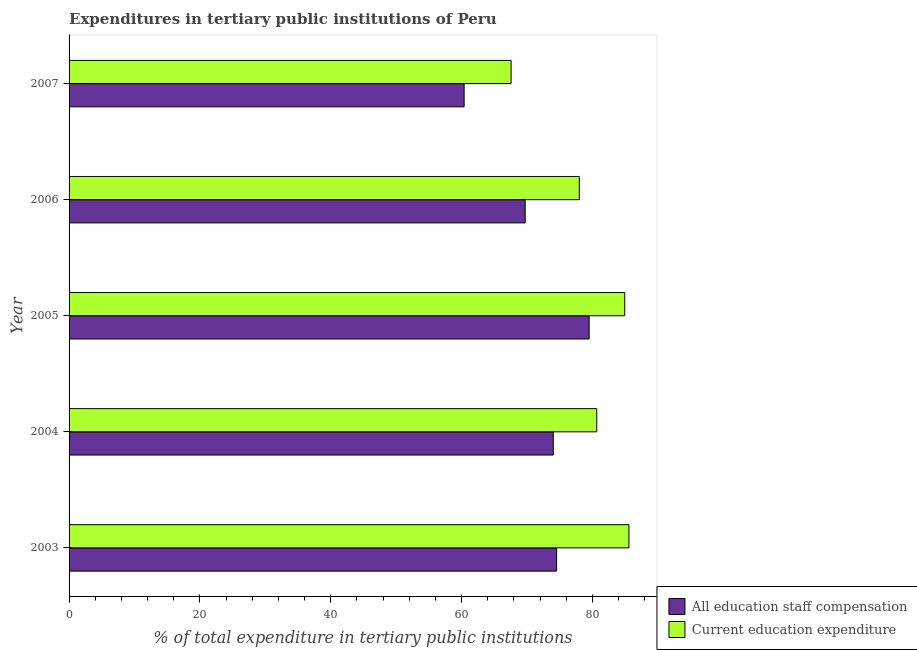How many groups of bars are there?
Your answer should be compact. 5. Are the number of bars on each tick of the Y-axis equal?
Ensure brevity in your answer.  Yes. How many bars are there on the 5th tick from the bottom?
Your answer should be compact. 2. What is the label of the 3rd group of bars from the top?
Keep it short and to the point. 2005. In how many cases, is the number of bars for a given year not equal to the number of legend labels?
Provide a short and direct response. 0. What is the expenditure in education in 2007?
Provide a short and direct response. 67.57. Across all years, what is the maximum expenditure in education?
Provide a short and direct response. 85.58. Across all years, what is the minimum expenditure in education?
Provide a short and direct response. 67.57. What is the total expenditure in education in the graph?
Provide a succinct answer. 396.74. What is the difference between the expenditure in education in 2003 and that in 2007?
Your answer should be compact. 18.01. What is the difference between the expenditure in education in 2006 and the expenditure in staff compensation in 2007?
Your answer should be very brief. 17.61. What is the average expenditure in staff compensation per year?
Your answer should be very brief. 71.63. In the year 2004, what is the difference between the expenditure in staff compensation and expenditure in education?
Provide a succinct answer. -6.65. In how many years, is the expenditure in education greater than 28 %?
Your answer should be very brief. 5. What is the ratio of the expenditure in staff compensation in 2006 to that in 2007?
Your answer should be compact. 1.16. Is the difference between the expenditure in education in 2003 and 2007 greater than the difference between the expenditure in staff compensation in 2003 and 2007?
Your response must be concise. Yes. What is the difference between the highest and the second highest expenditure in education?
Offer a terse response. 0.64. What is the difference between the highest and the lowest expenditure in staff compensation?
Your answer should be very brief. 19.11. What does the 2nd bar from the top in 2007 represents?
Keep it short and to the point. All education staff compensation. What does the 1st bar from the bottom in 2007 represents?
Ensure brevity in your answer.  All education staff compensation. What is the difference between two consecutive major ticks on the X-axis?
Your answer should be very brief. 20. Where does the legend appear in the graph?
Make the answer very short. Bottom right. What is the title of the graph?
Your answer should be compact. Expenditures in tertiary public institutions of Peru. What is the label or title of the X-axis?
Ensure brevity in your answer.  % of total expenditure in tertiary public institutions. What is the % of total expenditure in tertiary public institutions in All education staff compensation in 2003?
Your answer should be very brief. 74.52. What is the % of total expenditure in tertiary public institutions in Current education expenditure in 2003?
Your response must be concise. 85.58. What is the % of total expenditure in tertiary public institutions in All education staff compensation in 2004?
Offer a terse response. 74.02. What is the % of total expenditure in tertiary public institutions in Current education expenditure in 2004?
Provide a short and direct response. 80.66. What is the % of total expenditure in tertiary public institutions in All education staff compensation in 2005?
Your response must be concise. 79.5. What is the % of total expenditure in tertiary public institutions in Current education expenditure in 2005?
Give a very brief answer. 84.94. What is the % of total expenditure in tertiary public institutions of All education staff compensation in 2006?
Provide a succinct answer. 69.72. What is the % of total expenditure in tertiary public institutions in Current education expenditure in 2006?
Offer a very short reply. 77.99. What is the % of total expenditure in tertiary public institutions in All education staff compensation in 2007?
Give a very brief answer. 60.39. What is the % of total expenditure in tertiary public institutions of Current education expenditure in 2007?
Your response must be concise. 67.57. Across all years, what is the maximum % of total expenditure in tertiary public institutions in All education staff compensation?
Offer a terse response. 79.5. Across all years, what is the maximum % of total expenditure in tertiary public institutions of Current education expenditure?
Your answer should be compact. 85.58. Across all years, what is the minimum % of total expenditure in tertiary public institutions in All education staff compensation?
Offer a terse response. 60.39. Across all years, what is the minimum % of total expenditure in tertiary public institutions in Current education expenditure?
Your response must be concise. 67.57. What is the total % of total expenditure in tertiary public institutions of All education staff compensation in the graph?
Your response must be concise. 358.14. What is the total % of total expenditure in tertiary public institutions in Current education expenditure in the graph?
Your answer should be compact. 396.74. What is the difference between the % of total expenditure in tertiary public institutions in All education staff compensation in 2003 and that in 2004?
Keep it short and to the point. 0.51. What is the difference between the % of total expenditure in tertiary public institutions of Current education expenditure in 2003 and that in 2004?
Keep it short and to the point. 4.92. What is the difference between the % of total expenditure in tertiary public institutions in All education staff compensation in 2003 and that in 2005?
Give a very brief answer. -4.97. What is the difference between the % of total expenditure in tertiary public institutions of Current education expenditure in 2003 and that in 2005?
Provide a short and direct response. 0.64. What is the difference between the % of total expenditure in tertiary public institutions of All education staff compensation in 2003 and that in 2006?
Your response must be concise. 4.8. What is the difference between the % of total expenditure in tertiary public institutions of Current education expenditure in 2003 and that in 2006?
Your response must be concise. 7.59. What is the difference between the % of total expenditure in tertiary public institutions in All education staff compensation in 2003 and that in 2007?
Provide a short and direct response. 14.14. What is the difference between the % of total expenditure in tertiary public institutions in Current education expenditure in 2003 and that in 2007?
Offer a terse response. 18.01. What is the difference between the % of total expenditure in tertiary public institutions in All education staff compensation in 2004 and that in 2005?
Your answer should be very brief. -5.48. What is the difference between the % of total expenditure in tertiary public institutions of Current education expenditure in 2004 and that in 2005?
Your answer should be very brief. -4.28. What is the difference between the % of total expenditure in tertiary public institutions of All education staff compensation in 2004 and that in 2006?
Your answer should be very brief. 4.29. What is the difference between the % of total expenditure in tertiary public institutions in Current education expenditure in 2004 and that in 2006?
Keep it short and to the point. 2.67. What is the difference between the % of total expenditure in tertiary public institutions of All education staff compensation in 2004 and that in 2007?
Offer a terse response. 13.63. What is the difference between the % of total expenditure in tertiary public institutions of Current education expenditure in 2004 and that in 2007?
Offer a very short reply. 13.09. What is the difference between the % of total expenditure in tertiary public institutions of All education staff compensation in 2005 and that in 2006?
Give a very brief answer. 9.78. What is the difference between the % of total expenditure in tertiary public institutions of Current education expenditure in 2005 and that in 2006?
Provide a succinct answer. 6.94. What is the difference between the % of total expenditure in tertiary public institutions in All education staff compensation in 2005 and that in 2007?
Offer a very short reply. 19.11. What is the difference between the % of total expenditure in tertiary public institutions of Current education expenditure in 2005 and that in 2007?
Offer a very short reply. 17.37. What is the difference between the % of total expenditure in tertiary public institutions of All education staff compensation in 2006 and that in 2007?
Make the answer very short. 9.33. What is the difference between the % of total expenditure in tertiary public institutions in Current education expenditure in 2006 and that in 2007?
Offer a terse response. 10.43. What is the difference between the % of total expenditure in tertiary public institutions in All education staff compensation in 2003 and the % of total expenditure in tertiary public institutions in Current education expenditure in 2004?
Make the answer very short. -6.14. What is the difference between the % of total expenditure in tertiary public institutions in All education staff compensation in 2003 and the % of total expenditure in tertiary public institutions in Current education expenditure in 2005?
Provide a short and direct response. -10.41. What is the difference between the % of total expenditure in tertiary public institutions of All education staff compensation in 2003 and the % of total expenditure in tertiary public institutions of Current education expenditure in 2006?
Your answer should be very brief. -3.47. What is the difference between the % of total expenditure in tertiary public institutions of All education staff compensation in 2003 and the % of total expenditure in tertiary public institutions of Current education expenditure in 2007?
Make the answer very short. 6.96. What is the difference between the % of total expenditure in tertiary public institutions of All education staff compensation in 2004 and the % of total expenditure in tertiary public institutions of Current education expenditure in 2005?
Your answer should be very brief. -10.92. What is the difference between the % of total expenditure in tertiary public institutions of All education staff compensation in 2004 and the % of total expenditure in tertiary public institutions of Current education expenditure in 2006?
Offer a terse response. -3.98. What is the difference between the % of total expenditure in tertiary public institutions of All education staff compensation in 2004 and the % of total expenditure in tertiary public institutions of Current education expenditure in 2007?
Your answer should be very brief. 6.45. What is the difference between the % of total expenditure in tertiary public institutions in All education staff compensation in 2005 and the % of total expenditure in tertiary public institutions in Current education expenditure in 2006?
Provide a succinct answer. 1.5. What is the difference between the % of total expenditure in tertiary public institutions of All education staff compensation in 2005 and the % of total expenditure in tertiary public institutions of Current education expenditure in 2007?
Your answer should be compact. 11.93. What is the difference between the % of total expenditure in tertiary public institutions of All education staff compensation in 2006 and the % of total expenditure in tertiary public institutions of Current education expenditure in 2007?
Make the answer very short. 2.15. What is the average % of total expenditure in tertiary public institutions in All education staff compensation per year?
Provide a succinct answer. 71.63. What is the average % of total expenditure in tertiary public institutions in Current education expenditure per year?
Your answer should be very brief. 79.35. In the year 2003, what is the difference between the % of total expenditure in tertiary public institutions of All education staff compensation and % of total expenditure in tertiary public institutions of Current education expenditure?
Provide a short and direct response. -11.06. In the year 2004, what is the difference between the % of total expenditure in tertiary public institutions in All education staff compensation and % of total expenditure in tertiary public institutions in Current education expenditure?
Give a very brief answer. -6.65. In the year 2005, what is the difference between the % of total expenditure in tertiary public institutions of All education staff compensation and % of total expenditure in tertiary public institutions of Current education expenditure?
Your answer should be very brief. -5.44. In the year 2006, what is the difference between the % of total expenditure in tertiary public institutions in All education staff compensation and % of total expenditure in tertiary public institutions in Current education expenditure?
Make the answer very short. -8.27. In the year 2007, what is the difference between the % of total expenditure in tertiary public institutions of All education staff compensation and % of total expenditure in tertiary public institutions of Current education expenditure?
Your response must be concise. -7.18. What is the ratio of the % of total expenditure in tertiary public institutions of Current education expenditure in 2003 to that in 2004?
Your response must be concise. 1.06. What is the ratio of the % of total expenditure in tertiary public institutions in Current education expenditure in 2003 to that in 2005?
Offer a terse response. 1.01. What is the ratio of the % of total expenditure in tertiary public institutions in All education staff compensation in 2003 to that in 2006?
Offer a terse response. 1.07. What is the ratio of the % of total expenditure in tertiary public institutions in Current education expenditure in 2003 to that in 2006?
Keep it short and to the point. 1.1. What is the ratio of the % of total expenditure in tertiary public institutions in All education staff compensation in 2003 to that in 2007?
Provide a short and direct response. 1.23. What is the ratio of the % of total expenditure in tertiary public institutions in Current education expenditure in 2003 to that in 2007?
Provide a short and direct response. 1.27. What is the ratio of the % of total expenditure in tertiary public institutions of All education staff compensation in 2004 to that in 2005?
Ensure brevity in your answer.  0.93. What is the ratio of the % of total expenditure in tertiary public institutions in Current education expenditure in 2004 to that in 2005?
Your answer should be compact. 0.95. What is the ratio of the % of total expenditure in tertiary public institutions of All education staff compensation in 2004 to that in 2006?
Make the answer very short. 1.06. What is the ratio of the % of total expenditure in tertiary public institutions in Current education expenditure in 2004 to that in 2006?
Ensure brevity in your answer.  1.03. What is the ratio of the % of total expenditure in tertiary public institutions of All education staff compensation in 2004 to that in 2007?
Your response must be concise. 1.23. What is the ratio of the % of total expenditure in tertiary public institutions in Current education expenditure in 2004 to that in 2007?
Your response must be concise. 1.19. What is the ratio of the % of total expenditure in tertiary public institutions in All education staff compensation in 2005 to that in 2006?
Ensure brevity in your answer.  1.14. What is the ratio of the % of total expenditure in tertiary public institutions of Current education expenditure in 2005 to that in 2006?
Offer a terse response. 1.09. What is the ratio of the % of total expenditure in tertiary public institutions in All education staff compensation in 2005 to that in 2007?
Your answer should be compact. 1.32. What is the ratio of the % of total expenditure in tertiary public institutions of Current education expenditure in 2005 to that in 2007?
Your answer should be very brief. 1.26. What is the ratio of the % of total expenditure in tertiary public institutions of All education staff compensation in 2006 to that in 2007?
Give a very brief answer. 1.15. What is the ratio of the % of total expenditure in tertiary public institutions in Current education expenditure in 2006 to that in 2007?
Keep it short and to the point. 1.15. What is the difference between the highest and the second highest % of total expenditure in tertiary public institutions in All education staff compensation?
Ensure brevity in your answer.  4.97. What is the difference between the highest and the second highest % of total expenditure in tertiary public institutions of Current education expenditure?
Make the answer very short. 0.64. What is the difference between the highest and the lowest % of total expenditure in tertiary public institutions in All education staff compensation?
Keep it short and to the point. 19.11. What is the difference between the highest and the lowest % of total expenditure in tertiary public institutions in Current education expenditure?
Ensure brevity in your answer.  18.01. 